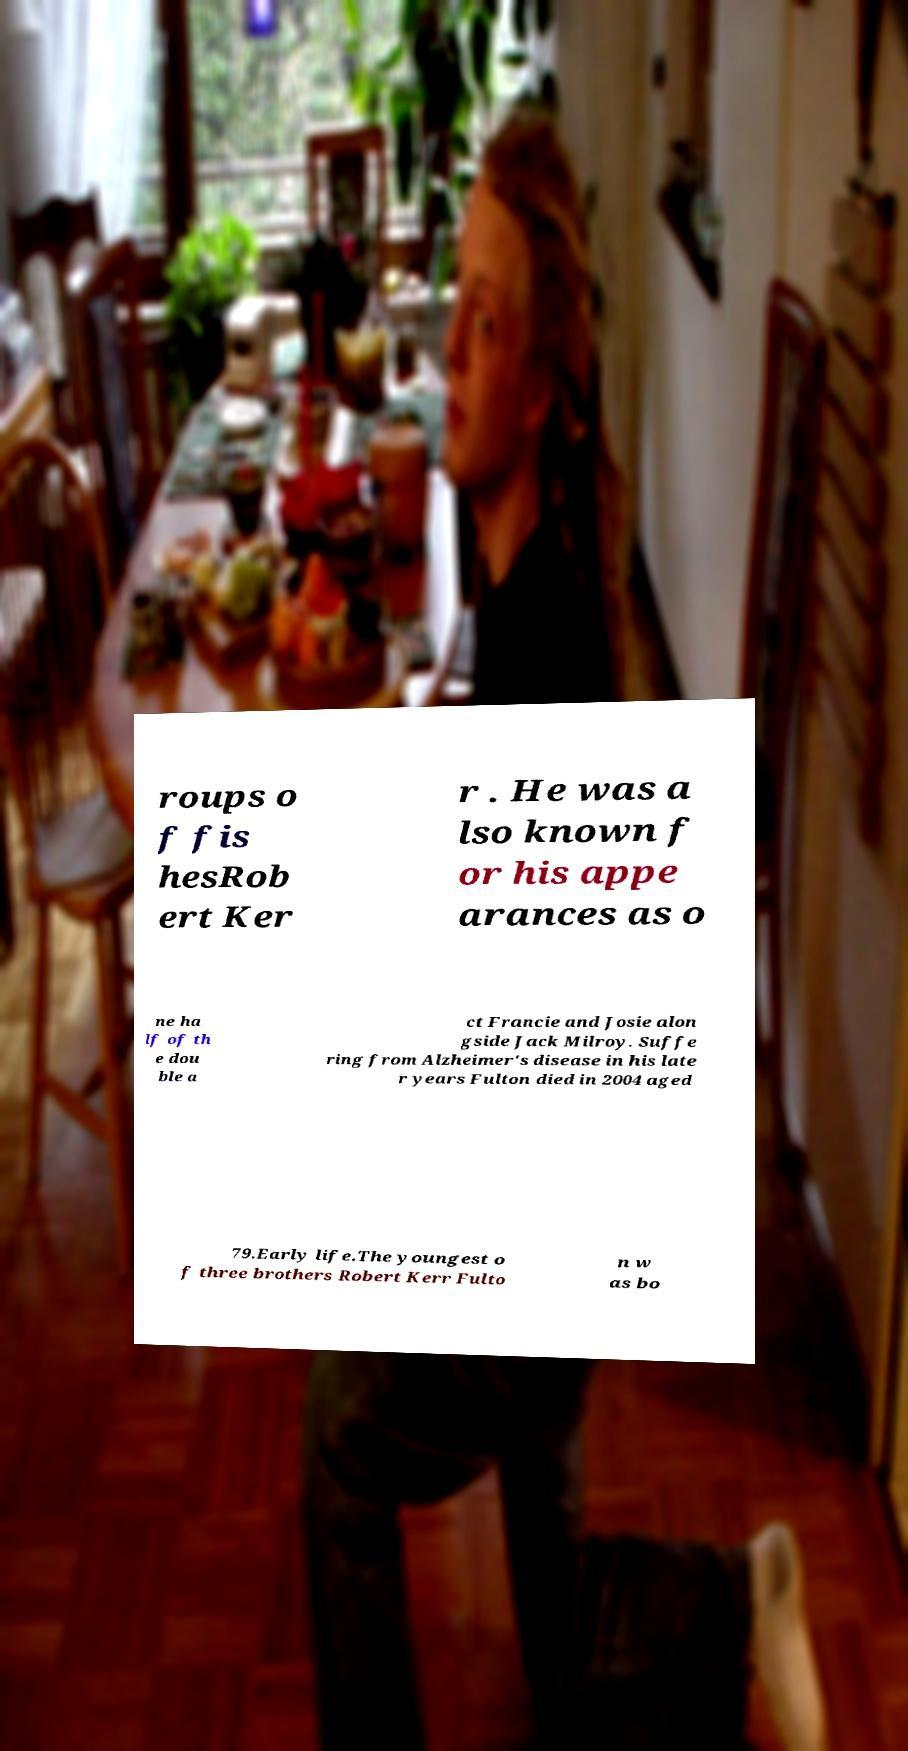Please read and relay the text visible in this image. What does it say? roups o f fis hesRob ert Ker r . He was a lso known f or his appe arances as o ne ha lf of th e dou ble a ct Francie and Josie alon gside Jack Milroy. Suffe ring from Alzheimer's disease in his late r years Fulton died in 2004 aged 79.Early life.The youngest o f three brothers Robert Kerr Fulto n w as bo 